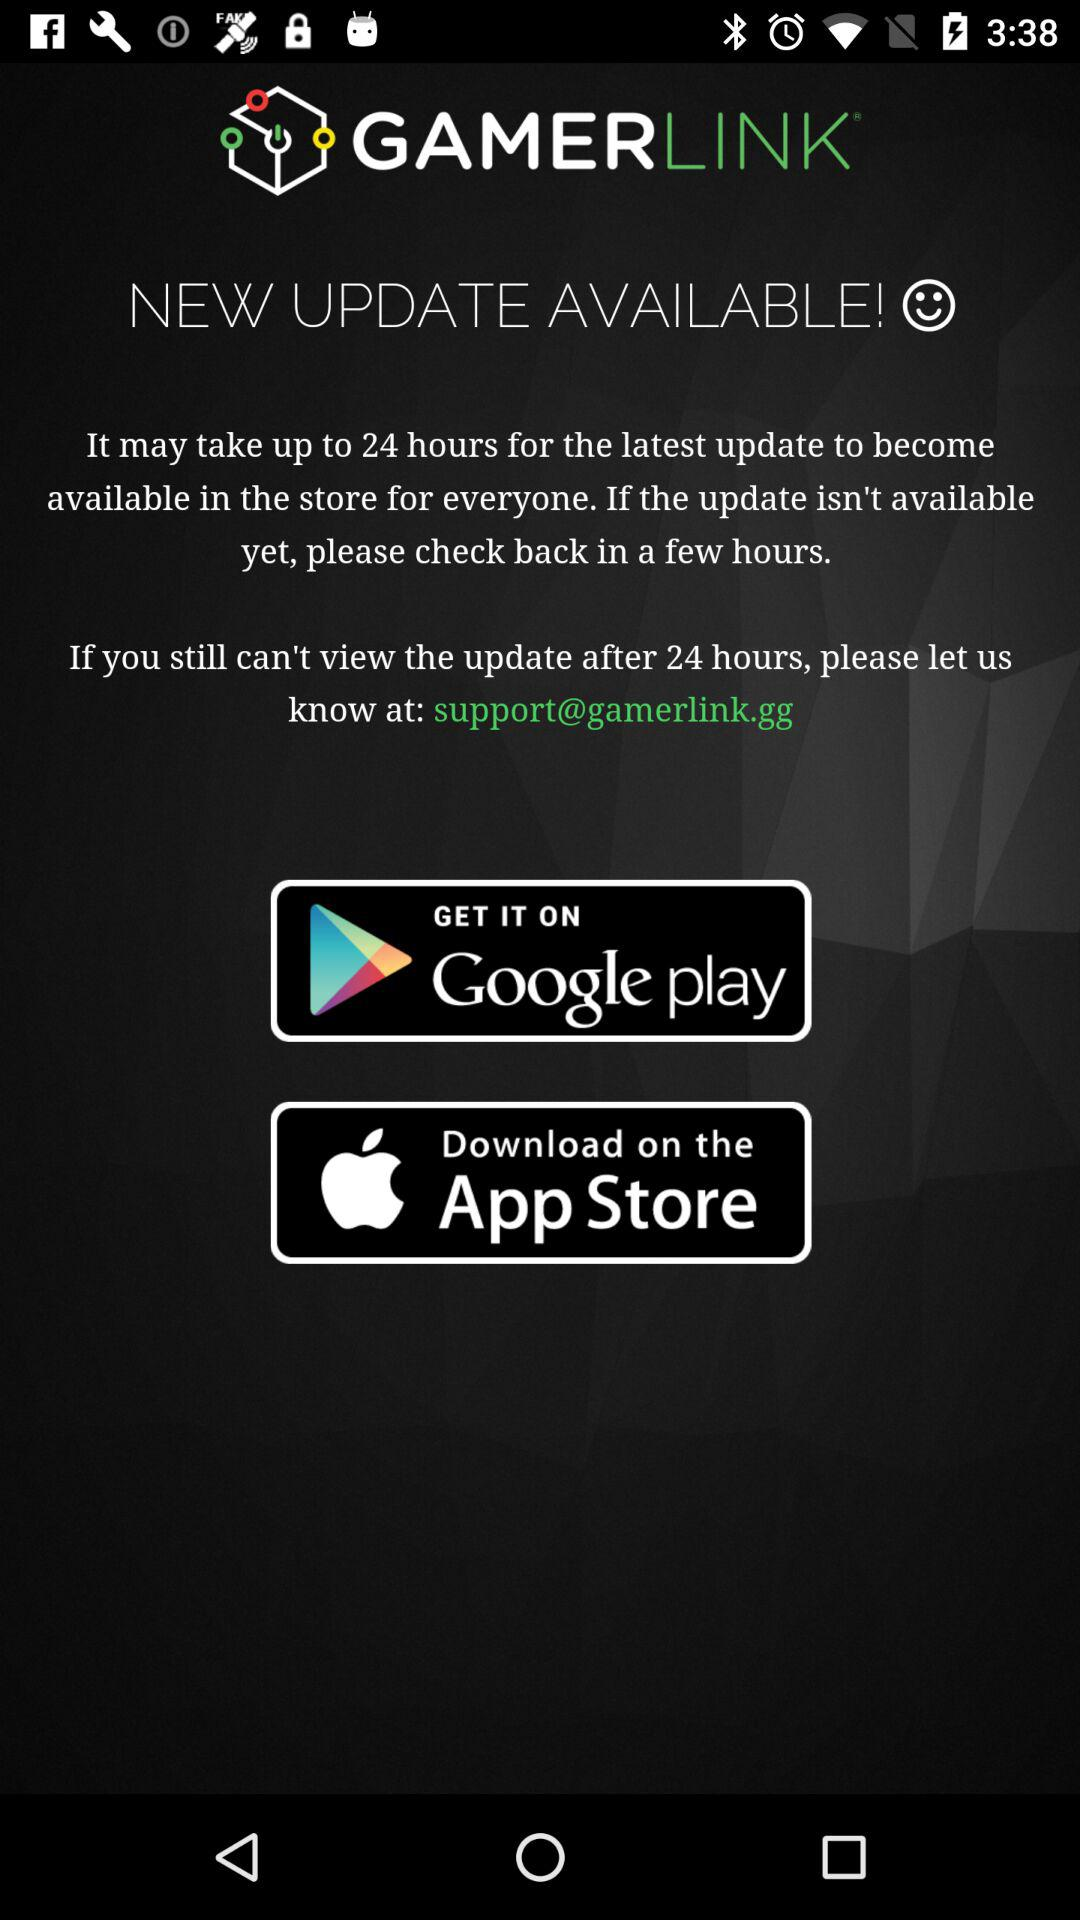What is the contact email address? The contact email address is support@gamerlink.gg. 